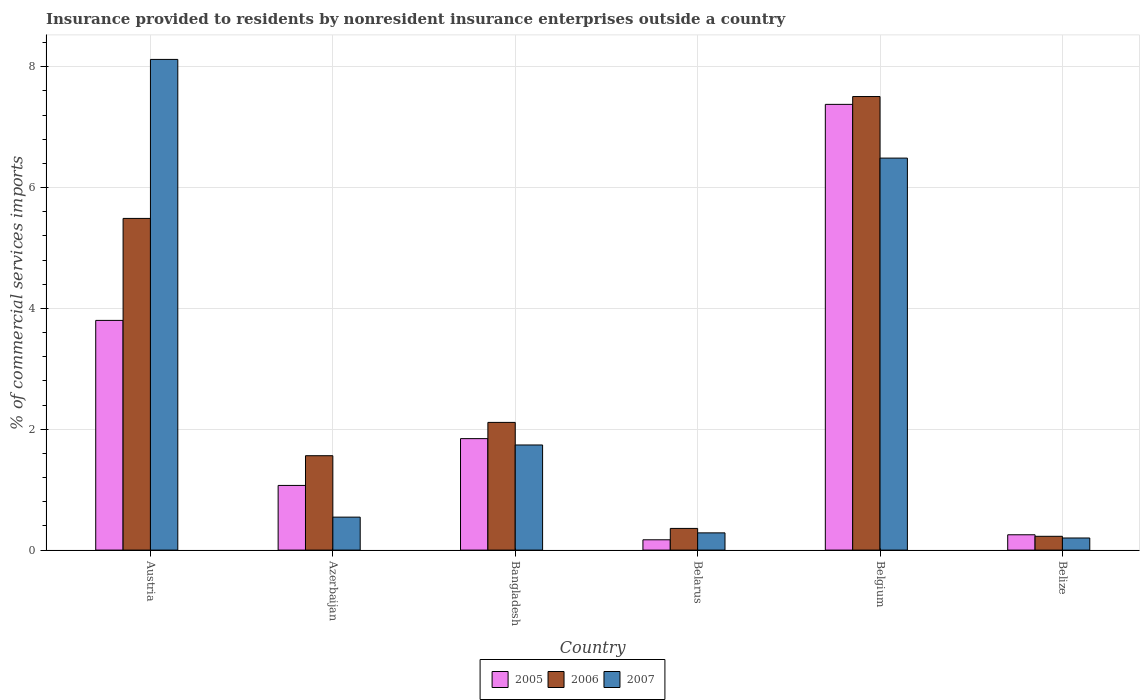What is the Insurance provided to residents in 2007 in Austria?
Keep it short and to the point. 8.12. Across all countries, what is the maximum Insurance provided to residents in 2007?
Keep it short and to the point. 8.12. Across all countries, what is the minimum Insurance provided to residents in 2006?
Your answer should be compact. 0.23. In which country was the Insurance provided to residents in 2005 maximum?
Your response must be concise. Belgium. In which country was the Insurance provided to residents in 2005 minimum?
Offer a terse response. Belarus. What is the total Insurance provided to residents in 2006 in the graph?
Give a very brief answer. 17.26. What is the difference between the Insurance provided to residents in 2006 in Bangladesh and that in Belarus?
Offer a very short reply. 1.75. What is the difference between the Insurance provided to residents in 2005 in Bangladesh and the Insurance provided to residents in 2007 in Azerbaijan?
Make the answer very short. 1.3. What is the average Insurance provided to residents in 2006 per country?
Your answer should be very brief. 2.88. What is the difference between the Insurance provided to residents of/in 2006 and Insurance provided to residents of/in 2005 in Belarus?
Provide a succinct answer. 0.19. In how many countries, is the Insurance provided to residents in 2005 greater than 5.2 %?
Your response must be concise. 1. What is the ratio of the Insurance provided to residents in 2005 in Bangladesh to that in Belize?
Offer a terse response. 7.27. Is the Insurance provided to residents in 2007 in Bangladesh less than that in Belarus?
Provide a short and direct response. No. What is the difference between the highest and the second highest Insurance provided to residents in 2006?
Your answer should be very brief. -3.38. What is the difference between the highest and the lowest Insurance provided to residents in 2007?
Give a very brief answer. 7.92. What does the 1st bar from the left in Austria represents?
Keep it short and to the point. 2005. Is it the case that in every country, the sum of the Insurance provided to residents in 2006 and Insurance provided to residents in 2005 is greater than the Insurance provided to residents in 2007?
Provide a short and direct response. Yes. How many bars are there?
Your answer should be very brief. 18. Are all the bars in the graph horizontal?
Provide a short and direct response. No. How many countries are there in the graph?
Your answer should be compact. 6. How many legend labels are there?
Provide a short and direct response. 3. What is the title of the graph?
Your answer should be very brief. Insurance provided to residents by nonresident insurance enterprises outside a country. Does "2013" appear as one of the legend labels in the graph?
Keep it short and to the point. No. What is the label or title of the Y-axis?
Ensure brevity in your answer.  % of commercial services imports. What is the % of commercial services imports of 2005 in Austria?
Provide a succinct answer. 3.8. What is the % of commercial services imports in 2006 in Austria?
Your answer should be very brief. 5.49. What is the % of commercial services imports of 2007 in Austria?
Provide a short and direct response. 8.12. What is the % of commercial services imports of 2005 in Azerbaijan?
Make the answer very short. 1.07. What is the % of commercial services imports of 2006 in Azerbaijan?
Provide a short and direct response. 1.56. What is the % of commercial services imports of 2007 in Azerbaijan?
Offer a terse response. 0.55. What is the % of commercial services imports in 2005 in Bangladesh?
Make the answer very short. 1.85. What is the % of commercial services imports of 2006 in Bangladesh?
Offer a very short reply. 2.11. What is the % of commercial services imports in 2007 in Bangladesh?
Provide a succinct answer. 1.74. What is the % of commercial services imports of 2005 in Belarus?
Offer a very short reply. 0.17. What is the % of commercial services imports in 2006 in Belarus?
Give a very brief answer. 0.36. What is the % of commercial services imports in 2007 in Belarus?
Keep it short and to the point. 0.29. What is the % of commercial services imports in 2005 in Belgium?
Provide a succinct answer. 7.38. What is the % of commercial services imports of 2006 in Belgium?
Offer a terse response. 7.51. What is the % of commercial services imports in 2007 in Belgium?
Provide a succinct answer. 6.49. What is the % of commercial services imports of 2005 in Belize?
Ensure brevity in your answer.  0.25. What is the % of commercial services imports in 2006 in Belize?
Provide a short and direct response. 0.23. What is the % of commercial services imports of 2007 in Belize?
Offer a terse response. 0.2. Across all countries, what is the maximum % of commercial services imports in 2005?
Ensure brevity in your answer.  7.38. Across all countries, what is the maximum % of commercial services imports of 2006?
Ensure brevity in your answer.  7.51. Across all countries, what is the maximum % of commercial services imports of 2007?
Offer a very short reply. 8.12. Across all countries, what is the minimum % of commercial services imports in 2005?
Make the answer very short. 0.17. Across all countries, what is the minimum % of commercial services imports in 2006?
Make the answer very short. 0.23. Across all countries, what is the minimum % of commercial services imports of 2007?
Your answer should be very brief. 0.2. What is the total % of commercial services imports of 2005 in the graph?
Keep it short and to the point. 14.52. What is the total % of commercial services imports of 2006 in the graph?
Offer a very short reply. 17.26. What is the total % of commercial services imports of 2007 in the graph?
Provide a short and direct response. 17.38. What is the difference between the % of commercial services imports in 2005 in Austria and that in Azerbaijan?
Your answer should be very brief. 2.73. What is the difference between the % of commercial services imports of 2006 in Austria and that in Azerbaijan?
Make the answer very short. 3.93. What is the difference between the % of commercial services imports in 2007 in Austria and that in Azerbaijan?
Your answer should be very brief. 7.58. What is the difference between the % of commercial services imports in 2005 in Austria and that in Bangladesh?
Provide a short and direct response. 1.96. What is the difference between the % of commercial services imports of 2006 in Austria and that in Bangladesh?
Provide a succinct answer. 3.38. What is the difference between the % of commercial services imports of 2007 in Austria and that in Bangladesh?
Provide a succinct answer. 6.38. What is the difference between the % of commercial services imports in 2005 in Austria and that in Belarus?
Provide a succinct answer. 3.63. What is the difference between the % of commercial services imports of 2006 in Austria and that in Belarus?
Your response must be concise. 5.13. What is the difference between the % of commercial services imports of 2007 in Austria and that in Belarus?
Make the answer very short. 7.84. What is the difference between the % of commercial services imports of 2005 in Austria and that in Belgium?
Offer a terse response. -3.58. What is the difference between the % of commercial services imports in 2006 in Austria and that in Belgium?
Your answer should be very brief. -2.02. What is the difference between the % of commercial services imports in 2007 in Austria and that in Belgium?
Provide a short and direct response. 1.63. What is the difference between the % of commercial services imports of 2005 in Austria and that in Belize?
Make the answer very short. 3.55. What is the difference between the % of commercial services imports in 2006 in Austria and that in Belize?
Provide a short and direct response. 5.26. What is the difference between the % of commercial services imports in 2007 in Austria and that in Belize?
Provide a short and direct response. 7.92. What is the difference between the % of commercial services imports in 2005 in Azerbaijan and that in Bangladesh?
Provide a short and direct response. -0.77. What is the difference between the % of commercial services imports in 2006 in Azerbaijan and that in Bangladesh?
Provide a succinct answer. -0.55. What is the difference between the % of commercial services imports in 2007 in Azerbaijan and that in Bangladesh?
Ensure brevity in your answer.  -1.19. What is the difference between the % of commercial services imports in 2005 in Azerbaijan and that in Belarus?
Your answer should be very brief. 0.9. What is the difference between the % of commercial services imports in 2006 in Azerbaijan and that in Belarus?
Give a very brief answer. 1.2. What is the difference between the % of commercial services imports of 2007 in Azerbaijan and that in Belarus?
Your answer should be compact. 0.26. What is the difference between the % of commercial services imports in 2005 in Azerbaijan and that in Belgium?
Your response must be concise. -6.31. What is the difference between the % of commercial services imports in 2006 in Azerbaijan and that in Belgium?
Make the answer very short. -5.95. What is the difference between the % of commercial services imports in 2007 in Azerbaijan and that in Belgium?
Offer a very short reply. -5.94. What is the difference between the % of commercial services imports of 2005 in Azerbaijan and that in Belize?
Make the answer very short. 0.82. What is the difference between the % of commercial services imports of 2006 in Azerbaijan and that in Belize?
Provide a short and direct response. 1.33. What is the difference between the % of commercial services imports of 2007 in Azerbaijan and that in Belize?
Provide a succinct answer. 0.35. What is the difference between the % of commercial services imports in 2005 in Bangladesh and that in Belarus?
Your answer should be compact. 1.67. What is the difference between the % of commercial services imports of 2006 in Bangladesh and that in Belarus?
Your response must be concise. 1.75. What is the difference between the % of commercial services imports of 2007 in Bangladesh and that in Belarus?
Provide a succinct answer. 1.45. What is the difference between the % of commercial services imports of 2005 in Bangladesh and that in Belgium?
Provide a succinct answer. -5.53. What is the difference between the % of commercial services imports of 2006 in Bangladesh and that in Belgium?
Offer a terse response. -5.39. What is the difference between the % of commercial services imports of 2007 in Bangladesh and that in Belgium?
Offer a very short reply. -4.75. What is the difference between the % of commercial services imports in 2005 in Bangladesh and that in Belize?
Offer a terse response. 1.59. What is the difference between the % of commercial services imports in 2006 in Bangladesh and that in Belize?
Provide a short and direct response. 1.89. What is the difference between the % of commercial services imports of 2007 in Bangladesh and that in Belize?
Make the answer very short. 1.54. What is the difference between the % of commercial services imports in 2005 in Belarus and that in Belgium?
Provide a short and direct response. -7.21. What is the difference between the % of commercial services imports in 2006 in Belarus and that in Belgium?
Give a very brief answer. -7.15. What is the difference between the % of commercial services imports of 2007 in Belarus and that in Belgium?
Offer a very short reply. -6.2. What is the difference between the % of commercial services imports in 2005 in Belarus and that in Belize?
Your answer should be compact. -0.08. What is the difference between the % of commercial services imports in 2006 in Belarus and that in Belize?
Keep it short and to the point. 0.13. What is the difference between the % of commercial services imports in 2007 in Belarus and that in Belize?
Ensure brevity in your answer.  0.08. What is the difference between the % of commercial services imports of 2005 in Belgium and that in Belize?
Your answer should be compact. 7.12. What is the difference between the % of commercial services imports of 2006 in Belgium and that in Belize?
Your answer should be compact. 7.28. What is the difference between the % of commercial services imports in 2007 in Belgium and that in Belize?
Your answer should be compact. 6.29. What is the difference between the % of commercial services imports of 2005 in Austria and the % of commercial services imports of 2006 in Azerbaijan?
Provide a succinct answer. 2.24. What is the difference between the % of commercial services imports in 2005 in Austria and the % of commercial services imports in 2007 in Azerbaijan?
Your response must be concise. 3.26. What is the difference between the % of commercial services imports of 2006 in Austria and the % of commercial services imports of 2007 in Azerbaijan?
Your answer should be very brief. 4.94. What is the difference between the % of commercial services imports of 2005 in Austria and the % of commercial services imports of 2006 in Bangladesh?
Your answer should be very brief. 1.69. What is the difference between the % of commercial services imports in 2005 in Austria and the % of commercial services imports in 2007 in Bangladesh?
Offer a very short reply. 2.06. What is the difference between the % of commercial services imports of 2006 in Austria and the % of commercial services imports of 2007 in Bangladesh?
Provide a short and direct response. 3.75. What is the difference between the % of commercial services imports of 2005 in Austria and the % of commercial services imports of 2006 in Belarus?
Your answer should be compact. 3.44. What is the difference between the % of commercial services imports of 2005 in Austria and the % of commercial services imports of 2007 in Belarus?
Your answer should be very brief. 3.52. What is the difference between the % of commercial services imports in 2006 in Austria and the % of commercial services imports in 2007 in Belarus?
Keep it short and to the point. 5.21. What is the difference between the % of commercial services imports of 2005 in Austria and the % of commercial services imports of 2006 in Belgium?
Keep it short and to the point. -3.71. What is the difference between the % of commercial services imports in 2005 in Austria and the % of commercial services imports in 2007 in Belgium?
Offer a terse response. -2.69. What is the difference between the % of commercial services imports of 2006 in Austria and the % of commercial services imports of 2007 in Belgium?
Your response must be concise. -1. What is the difference between the % of commercial services imports of 2005 in Austria and the % of commercial services imports of 2006 in Belize?
Offer a terse response. 3.57. What is the difference between the % of commercial services imports of 2005 in Austria and the % of commercial services imports of 2007 in Belize?
Make the answer very short. 3.6. What is the difference between the % of commercial services imports of 2006 in Austria and the % of commercial services imports of 2007 in Belize?
Your answer should be very brief. 5.29. What is the difference between the % of commercial services imports in 2005 in Azerbaijan and the % of commercial services imports in 2006 in Bangladesh?
Keep it short and to the point. -1.04. What is the difference between the % of commercial services imports of 2005 in Azerbaijan and the % of commercial services imports of 2007 in Bangladesh?
Offer a very short reply. -0.67. What is the difference between the % of commercial services imports of 2006 in Azerbaijan and the % of commercial services imports of 2007 in Bangladesh?
Make the answer very short. -0.18. What is the difference between the % of commercial services imports in 2005 in Azerbaijan and the % of commercial services imports in 2006 in Belarus?
Offer a very short reply. 0.71. What is the difference between the % of commercial services imports in 2005 in Azerbaijan and the % of commercial services imports in 2007 in Belarus?
Offer a terse response. 0.79. What is the difference between the % of commercial services imports of 2006 in Azerbaijan and the % of commercial services imports of 2007 in Belarus?
Make the answer very short. 1.28. What is the difference between the % of commercial services imports in 2005 in Azerbaijan and the % of commercial services imports in 2006 in Belgium?
Offer a very short reply. -6.44. What is the difference between the % of commercial services imports of 2005 in Azerbaijan and the % of commercial services imports of 2007 in Belgium?
Give a very brief answer. -5.42. What is the difference between the % of commercial services imports of 2006 in Azerbaijan and the % of commercial services imports of 2007 in Belgium?
Give a very brief answer. -4.93. What is the difference between the % of commercial services imports of 2005 in Azerbaijan and the % of commercial services imports of 2006 in Belize?
Provide a succinct answer. 0.84. What is the difference between the % of commercial services imports in 2005 in Azerbaijan and the % of commercial services imports in 2007 in Belize?
Provide a short and direct response. 0.87. What is the difference between the % of commercial services imports of 2006 in Azerbaijan and the % of commercial services imports of 2007 in Belize?
Provide a succinct answer. 1.36. What is the difference between the % of commercial services imports of 2005 in Bangladesh and the % of commercial services imports of 2006 in Belarus?
Make the answer very short. 1.49. What is the difference between the % of commercial services imports of 2005 in Bangladesh and the % of commercial services imports of 2007 in Belarus?
Keep it short and to the point. 1.56. What is the difference between the % of commercial services imports in 2006 in Bangladesh and the % of commercial services imports in 2007 in Belarus?
Your response must be concise. 1.83. What is the difference between the % of commercial services imports in 2005 in Bangladesh and the % of commercial services imports in 2006 in Belgium?
Provide a short and direct response. -5.66. What is the difference between the % of commercial services imports of 2005 in Bangladesh and the % of commercial services imports of 2007 in Belgium?
Make the answer very short. -4.64. What is the difference between the % of commercial services imports of 2006 in Bangladesh and the % of commercial services imports of 2007 in Belgium?
Give a very brief answer. -4.38. What is the difference between the % of commercial services imports in 2005 in Bangladesh and the % of commercial services imports in 2006 in Belize?
Your answer should be compact. 1.62. What is the difference between the % of commercial services imports in 2005 in Bangladesh and the % of commercial services imports in 2007 in Belize?
Your answer should be compact. 1.64. What is the difference between the % of commercial services imports in 2006 in Bangladesh and the % of commercial services imports in 2007 in Belize?
Your answer should be very brief. 1.91. What is the difference between the % of commercial services imports of 2005 in Belarus and the % of commercial services imports of 2006 in Belgium?
Make the answer very short. -7.34. What is the difference between the % of commercial services imports in 2005 in Belarus and the % of commercial services imports in 2007 in Belgium?
Make the answer very short. -6.32. What is the difference between the % of commercial services imports of 2006 in Belarus and the % of commercial services imports of 2007 in Belgium?
Your answer should be compact. -6.13. What is the difference between the % of commercial services imports in 2005 in Belarus and the % of commercial services imports in 2006 in Belize?
Your response must be concise. -0.06. What is the difference between the % of commercial services imports in 2005 in Belarus and the % of commercial services imports in 2007 in Belize?
Provide a succinct answer. -0.03. What is the difference between the % of commercial services imports in 2006 in Belarus and the % of commercial services imports in 2007 in Belize?
Provide a succinct answer. 0.16. What is the difference between the % of commercial services imports of 2005 in Belgium and the % of commercial services imports of 2006 in Belize?
Give a very brief answer. 7.15. What is the difference between the % of commercial services imports of 2005 in Belgium and the % of commercial services imports of 2007 in Belize?
Offer a terse response. 7.18. What is the difference between the % of commercial services imports in 2006 in Belgium and the % of commercial services imports in 2007 in Belize?
Offer a terse response. 7.31. What is the average % of commercial services imports in 2005 per country?
Make the answer very short. 2.42. What is the average % of commercial services imports in 2006 per country?
Make the answer very short. 2.88. What is the average % of commercial services imports in 2007 per country?
Make the answer very short. 2.9. What is the difference between the % of commercial services imports in 2005 and % of commercial services imports in 2006 in Austria?
Give a very brief answer. -1.69. What is the difference between the % of commercial services imports of 2005 and % of commercial services imports of 2007 in Austria?
Provide a succinct answer. -4.32. What is the difference between the % of commercial services imports in 2006 and % of commercial services imports in 2007 in Austria?
Offer a terse response. -2.63. What is the difference between the % of commercial services imports of 2005 and % of commercial services imports of 2006 in Azerbaijan?
Your answer should be very brief. -0.49. What is the difference between the % of commercial services imports of 2005 and % of commercial services imports of 2007 in Azerbaijan?
Your answer should be compact. 0.52. What is the difference between the % of commercial services imports of 2006 and % of commercial services imports of 2007 in Azerbaijan?
Keep it short and to the point. 1.02. What is the difference between the % of commercial services imports of 2005 and % of commercial services imports of 2006 in Bangladesh?
Offer a very short reply. -0.27. What is the difference between the % of commercial services imports in 2005 and % of commercial services imports in 2007 in Bangladesh?
Give a very brief answer. 0.11. What is the difference between the % of commercial services imports of 2006 and % of commercial services imports of 2007 in Bangladesh?
Give a very brief answer. 0.37. What is the difference between the % of commercial services imports of 2005 and % of commercial services imports of 2006 in Belarus?
Offer a very short reply. -0.19. What is the difference between the % of commercial services imports in 2005 and % of commercial services imports in 2007 in Belarus?
Your response must be concise. -0.11. What is the difference between the % of commercial services imports of 2006 and % of commercial services imports of 2007 in Belarus?
Your answer should be very brief. 0.07. What is the difference between the % of commercial services imports in 2005 and % of commercial services imports in 2006 in Belgium?
Your answer should be very brief. -0.13. What is the difference between the % of commercial services imports in 2005 and % of commercial services imports in 2007 in Belgium?
Give a very brief answer. 0.89. What is the difference between the % of commercial services imports of 2006 and % of commercial services imports of 2007 in Belgium?
Your answer should be very brief. 1.02. What is the difference between the % of commercial services imports in 2005 and % of commercial services imports in 2006 in Belize?
Give a very brief answer. 0.03. What is the difference between the % of commercial services imports in 2005 and % of commercial services imports in 2007 in Belize?
Your response must be concise. 0.05. What is the difference between the % of commercial services imports of 2006 and % of commercial services imports of 2007 in Belize?
Provide a short and direct response. 0.03. What is the ratio of the % of commercial services imports in 2005 in Austria to that in Azerbaijan?
Your response must be concise. 3.55. What is the ratio of the % of commercial services imports in 2006 in Austria to that in Azerbaijan?
Your answer should be compact. 3.51. What is the ratio of the % of commercial services imports of 2007 in Austria to that in Azerbaijan?
Give a very brief answer. 14.88. What is the ratio of the % of commercial services imports of 2005 in Austria to that in Bangladesh?
Your answer should be compact. 2.06. What is the ratio of the % of commercial services imports of 2006 in Austria to that in Bangladesh?
Provide a short and direct response. 2.6. What is the ratio of the % of commercial services imports of 2007 in Austria to that in Bangladesh?
Provide a short and direct response. 4.67. What is the ratio of the % of commercial services imports of 2005 in Austria to that in Belarus?
Make the answer very short. 22.27. What is the ratio of the % of commercial services imports in 2006 in Austria to that in Belarus?
Ensure brevity in your answer.  15.29. What is the ratio of the % of commercial services imports of 2007 in Austria to that in Belarus?
Your response must be concise. 28.48. What is the ratio of the % of commercial services imports in 2005 in Austria to that in Belgium?
Provide a short and direct response. 0.52. What is the ratio of the % of commercial services imports of 2006 in Austria to that in Belgium?
Offer a terse response. 0.73. What is the ratio of the % of commercial services imports in 2007 in Austria to that in Belgium?
Keep it short and to the point. 1.25. What is the ratio of the % of commercial services imports in 2005 in Austria to that in Belize?
Your response must be concise. 14.99. What is the ratio of the % of commercial services imports in 2006 in Austria to that in Belize?
Provide a succinct answer. 24.05. What is the ratio of the % of commercial services imports of 2007 in Austria to that in Belize?
Give a very brief answer. 40.51. What is the ratio of the % of commercial services imports in 2005 in Azerbaijan to that in Bangladesh?
Your answer should be compact. 0.58. What is the ratio of the % of commercial services imports of 2006 in Azerbaijan to that in Bangladesh?
Give a very brief answer. 0.74. What is the ratio of the % of commercial services imports of 2007 in Azerbaijan to that in Bangladesh?
Keep it short and to the point. 0.31. What is the ratio of the % of commercial services imports in 2005 in Azerbaijan to that in Belarus?
Ensure brevity in your answer.  6.27. What is the ratio of the % of commercial services imports of 2006 in Azerbaijan to that in Belarus?
Provide a succinct answer. 4.35. What is the ratio of the % of commercial services imports of 2007 in Azerbaijan to that in Belarus?
Give a very brief answer. 1.91. What is the ratio of the % of commercial services imports in 2005 in Azerbaijan to that in Belgium?
Ensure brevity in your answer.  0.15. What is the ratio of the % of commercial services imports of 2006 in Azerbaijan to that in Belgium?
Provide a short and direct response. 0.21. What is the ratio of the % of commercial services imports in 2007 in Azerbaijan to that in Belgium?
Your answer should be very brief. 0.08. What is the ratio of the % of commercial services imports of 2005 in Azerbaijan to that in Belize?
Make the answer very short. 4.22. What is the ratio of the % of commercial services imports of 2006 in Azerbaijan to that in Belize?
Your answer should be very brief. 6.84. What is the ratio of the % of commercial services imports in 2007 in Azerbaijan to that in Belize?
Offer a very short reply. 2.72. What is the ratio of the % of commercial services imports of 2005 in Bangladesh to that in Belarus?
Give a very brief answer. 10.81. What is the ratio of the % of commercial services imports in 2006 in Bangladesh to that in Belarus?
Your answer should be very brief. 5.89. What is the ratio of the % of commercial services imports in 2007 in Bangladesh to that in Belarus?
Offer a very short reply. 6.1. What is the ratio of the % of commercial services imports of 2005 in Bangladesh to that in Belgium?
Provide a succinct answer. 0.25. What is the ratio of the % of commercial services imports in 2006 in Bangladesh to that in Belgium?
Make the answer very short. 0.28. What is the ratio of the % of commercial services imports of 2007 in Bangladesh to that in Belgium?
Provide a short and direct response. 0.27. What is the ratio of the % of commercial services imports of 2005 in Bangladesh to that in Belize?
Provide a succinct answer. 7.27. What is the ratio of the % of commercial services imports in 2006 in Bangladesh to that in Belize?
Offer a very short reply. 9.26. What is the ratio of the % of commercial services imports of 2007 in Bangladesh to that in Belize?
Your response must be concise. 8.68. What is the ratio of the % of commercial services imports in 2005 in Belarus to that in Belgium?
Provide a short and direct response. 0.02. What is the ratio of the % of commercial services imports in 2006 in Belarus to that in Belgium?
Ensure brevity in your answer.  0.05. What is the ratio of the % of commercial services imports in 2007 in Belarus to that in Belgium?
Provide a succinct answer. 0.04. What is the ratio of the % of commercial services imports of 2005 in Belarus to that in Belize?
Your answer should be compact. 0.67. What is the ratio of the % of commercial services imports in 2006 in Belarus to that in Belize?
Offer a very short reply. 1.57. What is the ratio of the % of commercial services imports in 2007 in Belarus to that in Belize?
Keep it short and to the point. 1.42. What is the ratio of the % of commercial services imports of 2005 in Belgium to that in Belize?
Your response must be concise. 29.09. What is the ratio of the % of commercial services imports in 2006 in Belgium to that in Belize?
Give a very brief answer. 32.89. What is the ratio of the % of commercial services imports of 2007 in Belgium to that in Belize?
Your answer should be compact. 32.36. What is the difference between the highest and the second highest % of commercial services imports in 2005?
Your answer should be compact. 3.58. What is the difference between the highest and the second highest % of commercial services imports in 2006?
Keep it short and to the point. 2.02. What is the difference between the highest and the second highest % of commercial services imports in 2007?
Offer a very short reply. 1.63. What is the difference between the highest and the lowest % of commercial services imports in 2005?
Your response must be concise. 7.21. What is the difference between the highest and the lowest % of commercial services imports in 2006?
Make the answer very short. 7.28. What is the difference between the highest and the lowest % of commercial services imports in 2007?
Offer a very short reply. 7.92. 